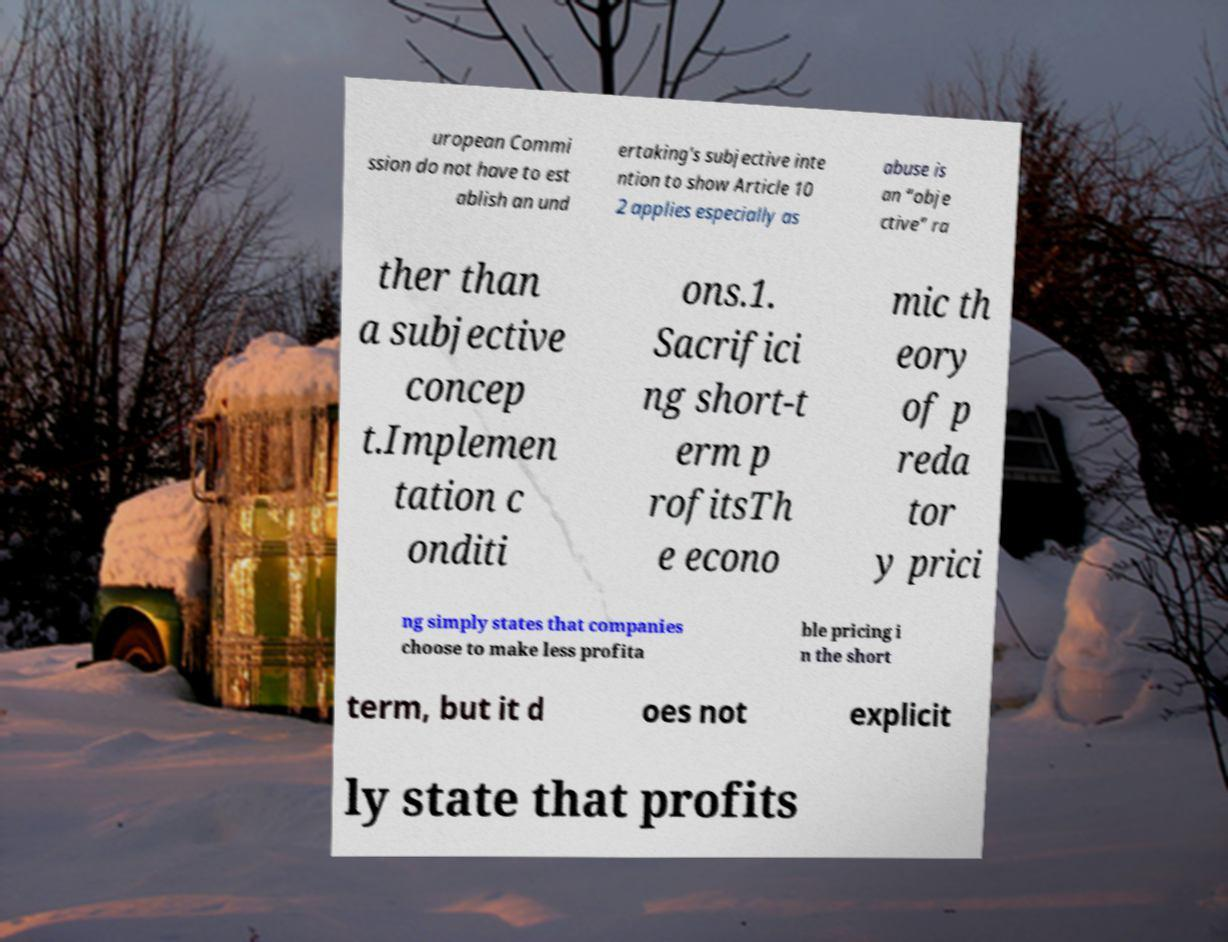Could you extract and type out the text from this image? uropean Commi ssion do not have to est ablish an und ertaking's subjective inte ntion to show Article 10 2 applies especially as abuse is an “obje ctive” ra ther than a subjective concep t.Implemen tation c onditi ons.1. Sacrifici ng short-t erm p rofitsTh e econo mic th eory of p reda tor y prici ng simply states that companies choose to make less profita ble pricing i n the short term, but it d oes not explicit ly state that profits 